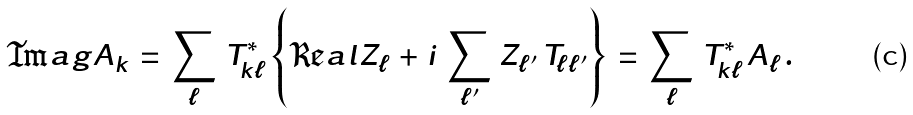Convert formula to latex. <formula><loc_0><loc_0><loc_500><loc_500>\Im a g { A _ { k } } \, = \, \sum _ { \ell } \, T _ { k \ell } ^ { \ast } \left \{ \Re a l { Z _ { \ell } } \, + \, i \, \sum _ { \ell ^ { \prime } } \, Z _ { \ell ^ { \prime } } \, T _ { \ell \ell ^ { \prime } } \right \} \, = \, \sum _ { \ell } \, T _ { k \ell } ^ { \ast } \, A _ { \ell } \, .</formula> 